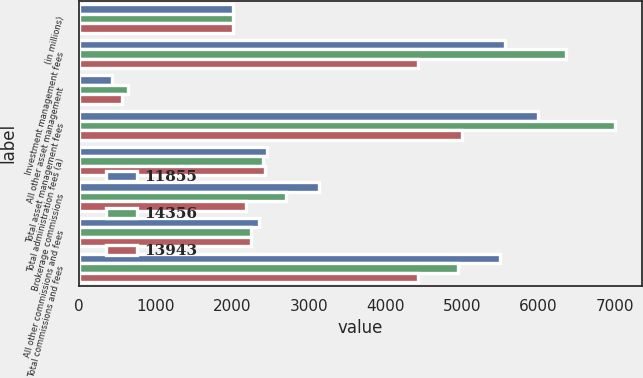Convert chart. <chart><loc_0><loc_0><loc_500><loc_500><stacked_bar_chart><ecel><fcel>(in millions)<fcel>Investment management fees<fcel>All other asset management<fcel>Total asset management fees<fcel>Total administration fees (a)<fcel>Brokerage commissions<fcel>All other commissions and fees<fcel>Total commissions and fees<nl><fcel>11855<fcel>2008<fcel>5562<fcel>432<fcel>5994<fcel>2452<fcel>3141<fcel>2356<fcel>5497<nl><fcel>14356<fcel>2007<fcel>6364<fcel>639<fcel>7003<fcel>2401<fcel>2702<fcel>2250<fcel>4952<nl><fcel>13943<fcel>2006<fcel>4429<fcel>567<fcel>4996<fcel>2430<fcel>2184<fcel>2245<fcel>4429<nl></chart> 